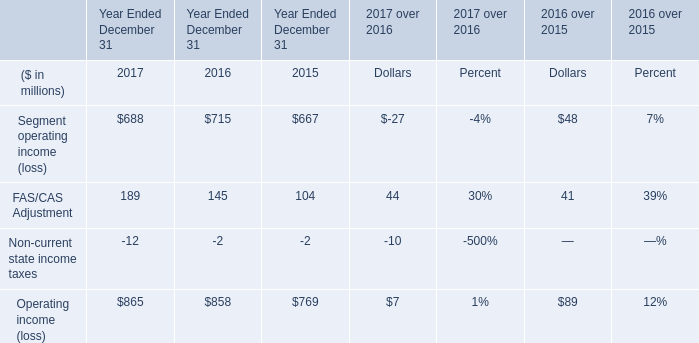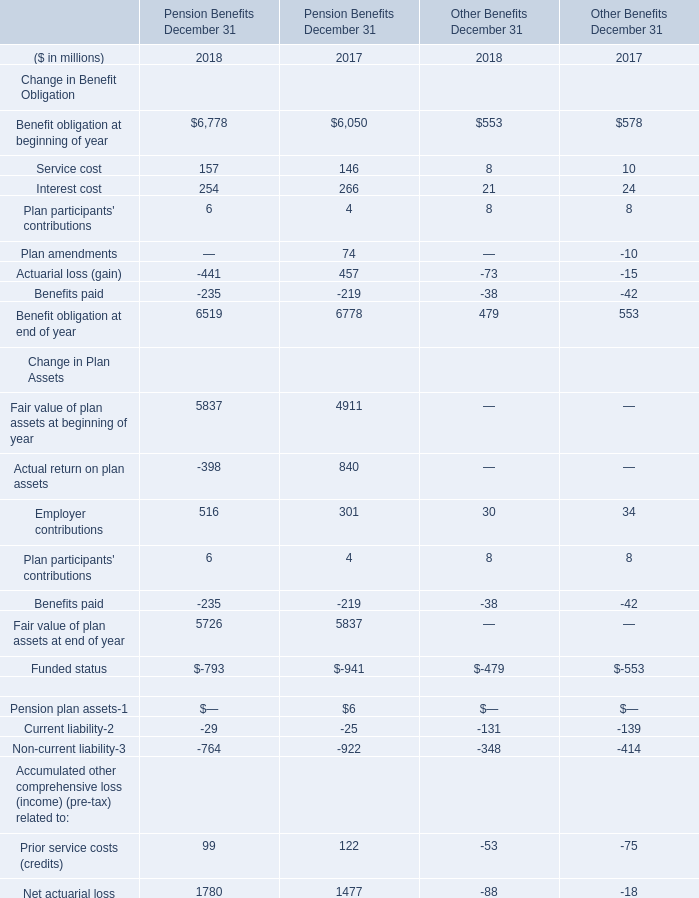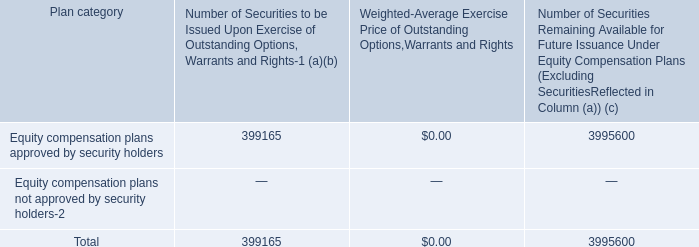Which year is Benefit obligation at end of year the least, in term of Pension Benefits December 31? 
Answer: 2018. In which year is Benefit obligation at end of year smaller than Benefit obligation at beginning of year,in terms of Pension Benefits December 31? 
Answer: 2018. 